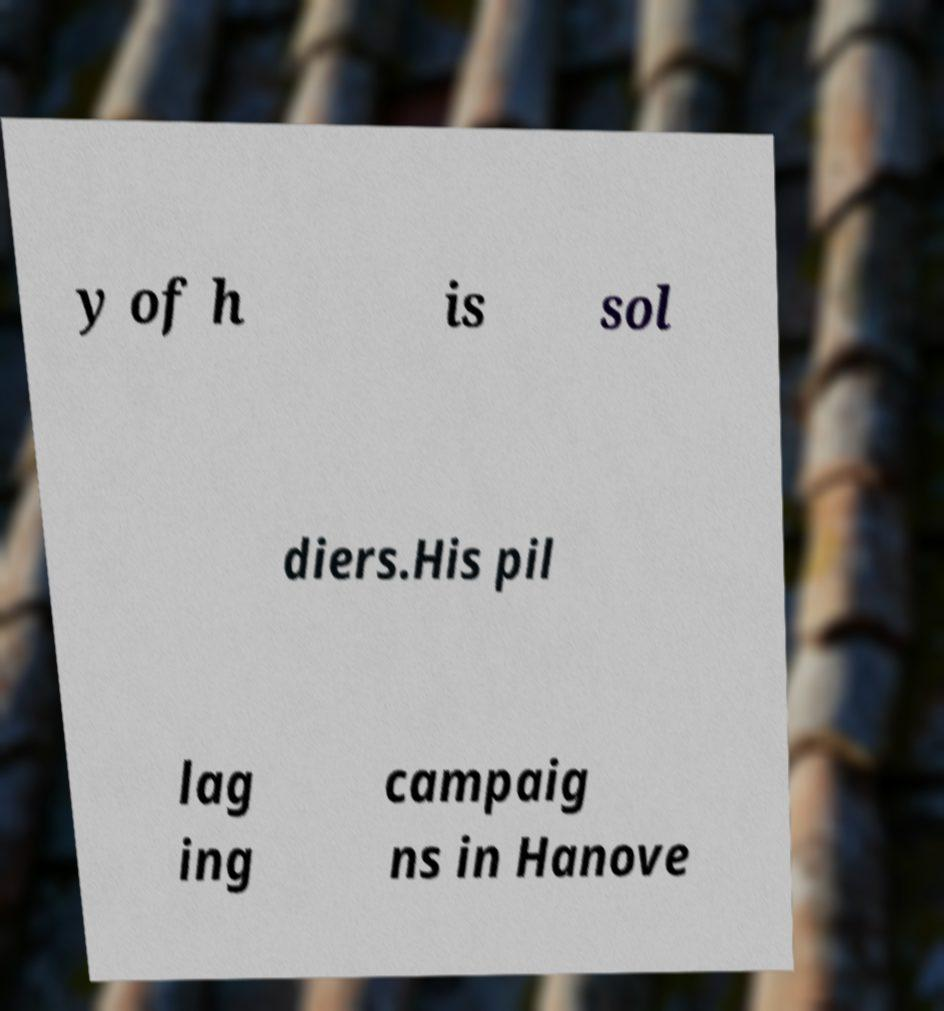Can you accurately transcribe the text from the provided image for me? y of h is sol diers.His pil lag ing campaig ns in Hanove 